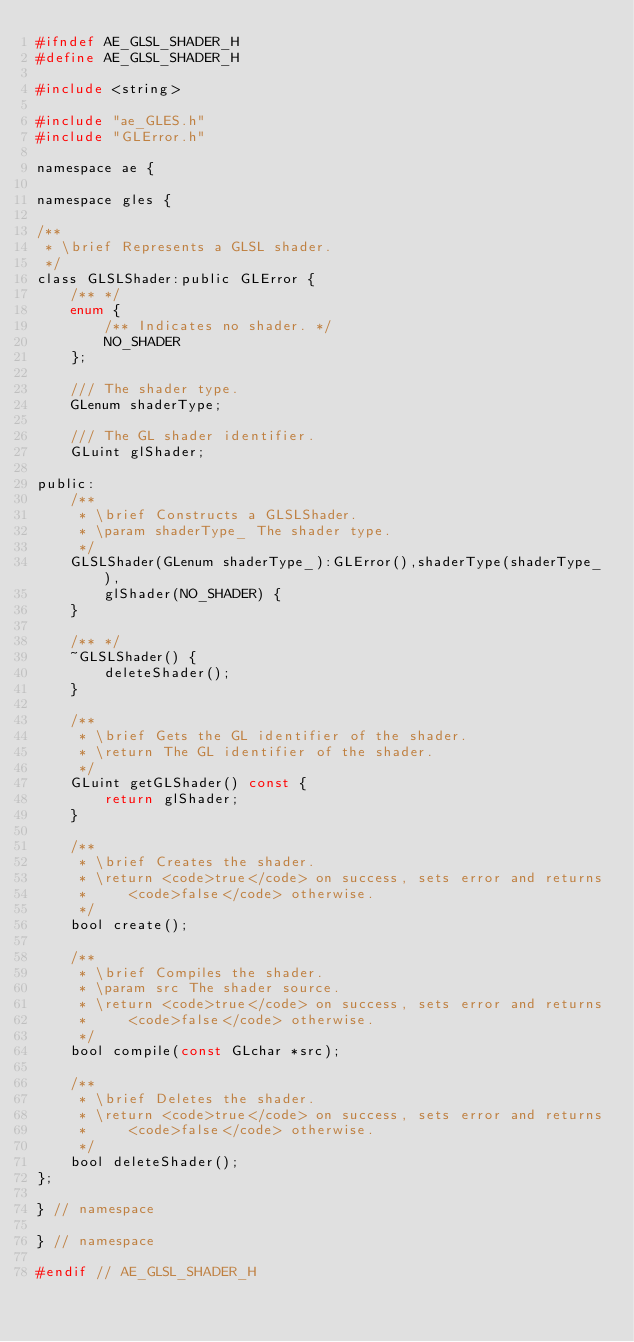Convert code to text. <code><loc_0><loc_0><loc_500><loc_500><_C_>#ifndef AE_GLSL_SHADER_H
#define AE_GLSL_SHADER_H

#include <string>

#include "ae_GLES.h"
#include "GLError.h"

namespace ae {

namespace gles {
  
/**
 * \brief Represents a GLSL shader.
 */
class GLSLShader:public GLError {
    /** */
    enum {
        /** Indicates no shader. */
        NO_SHADER
    };
    
    /// The shader type.
    GLenum shaderType;
    
    /// The GL shader identifier.
    GLuint glShader;
    
public:
    /**
     * \brief Constructs a GLSLShader.
     * \param shaderType_ The shader type.
     */
    GLSLShader(GLenum shaderType_):GLError(),shaderType(shaderType_),
        glShader(NO_SHADER) {
    }
    
    /** */
    ~GLSLShader() {
        deleteShader();
    }
    
    /**
     * \brief Gets the GL identifier of the shader.
     * \return The GL identifier of the shader.
     */
    GLuint getGLShader() const {
        return glShader;
    }    
    
    /**
     * \brief Creates the shader.
     * \return <code>true</code> on success, sets error and returns
     *     <code>false</code> otherwise.
     */
    bool create();
    
    /**
     * \brief Compiles the shader.
     * \param src The shader source.
     * \return <code>true</code> on success, sets error and returns
     *     <code>false</code> otherwise.
     */
    bool compile(const GLchar *src);
    
    /**
     * \brief Deletes the shader.
     * \return <code>true</code> on success, sets error and returns
     *     <code>false</code> otherwise.
     */
    bool deleteShader();
};
    
} // namespace

} // namespace

#endif // AE_GLSL_SHADER_H</code> 